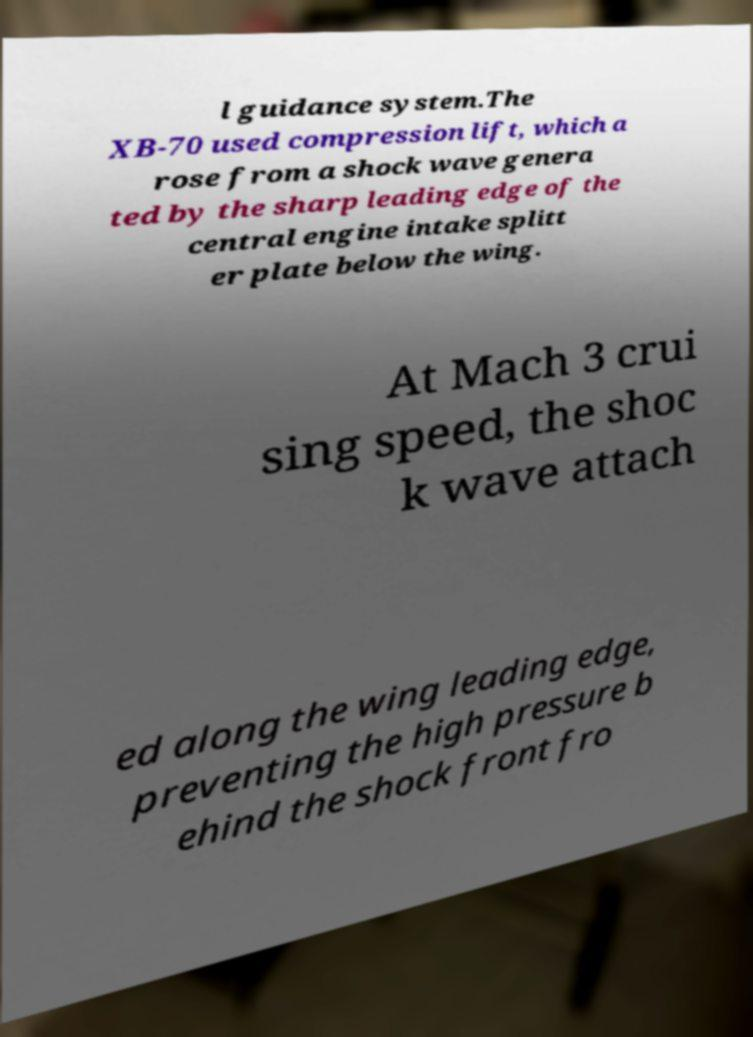Could you assist in decoding the text presented in this image and type it out clearly? l guidance system.The XB-70 used compression lift, which a rose from a shock wave genera ted by the sharp leading edge of the central engine intake splitt er plate below the wing. At Mach 3 crui sing speed, the shoc k wave attach ed along the wing leading edge, preventing the high pressure b ehind the shock front fro 